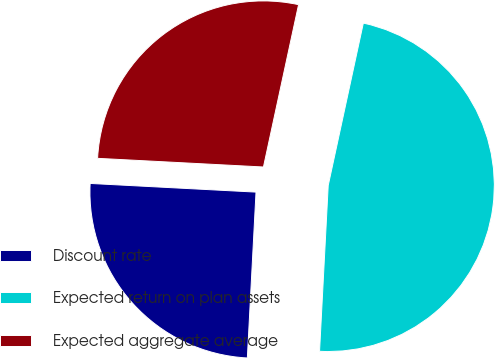Convert chart to OTSL. <chart><loc_0><loc_0><loc_500><loc_500><pie_chart><fcel>Discount rate<fcel>Expected return on plan assets<fcel>Expected aggregate average<nl><fcel>25.0%<fcel>47.44%<fcel>27.56%<nl></chart> 